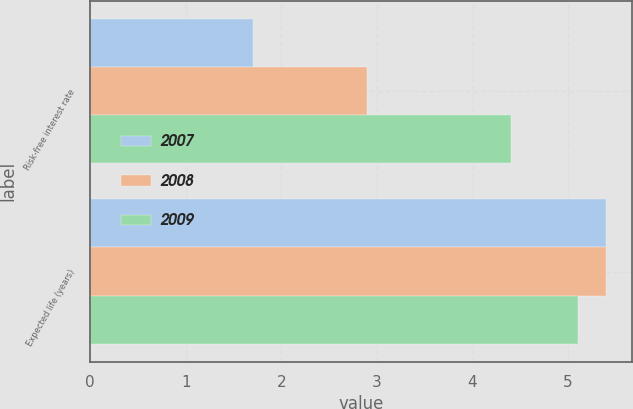<chart> <loc_0><loc_0><loc_500><loc_500><stacked_bar_chart><ecel><fcel>Risk-free interest rate<fcel>Expected life (years)<nl><fcel>2007<fcel>1.7<fcel>5.4<nl><fcel>2008<fcel>2.9<fcel>5.4<nl><fcel>2009<fcel>4.4<fcel>5.1<nl></chart> 